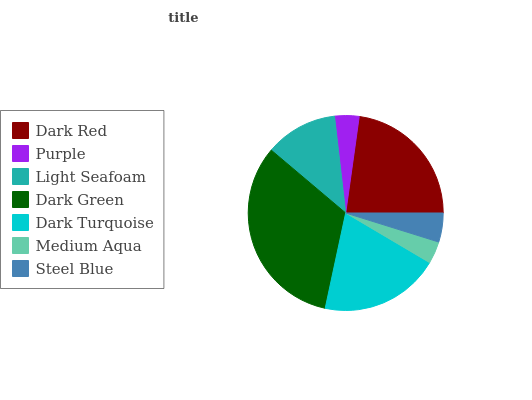Is Medium Aqua the minimum?
Answer yes or no. Yes. Is Dark Green the maximum?
Answer yes or no. Yes. Is Purple the minimum?
Answer yes or no. No. Is Purple the maximum?
Answer yes or no. No. Is Dark Red greater than Purple?
Answer yes or no. Yes. Is Purple less than Dark Red?
Answer yes or no. Yes. Is Purple greater than Dark Red?
Answer yes or no. No. Is Dark Red less than Purple?
Answer yes or no. No. Is Light Seafoam the high median?
Answer yes or no. Yes. Is Light Seafoam the low median?
Answer yes or no. Yes. Is Steel Blue the high median?
Answer yes or no. No. Is Dark Turquoise the low median?
Answer yes or no. No. 